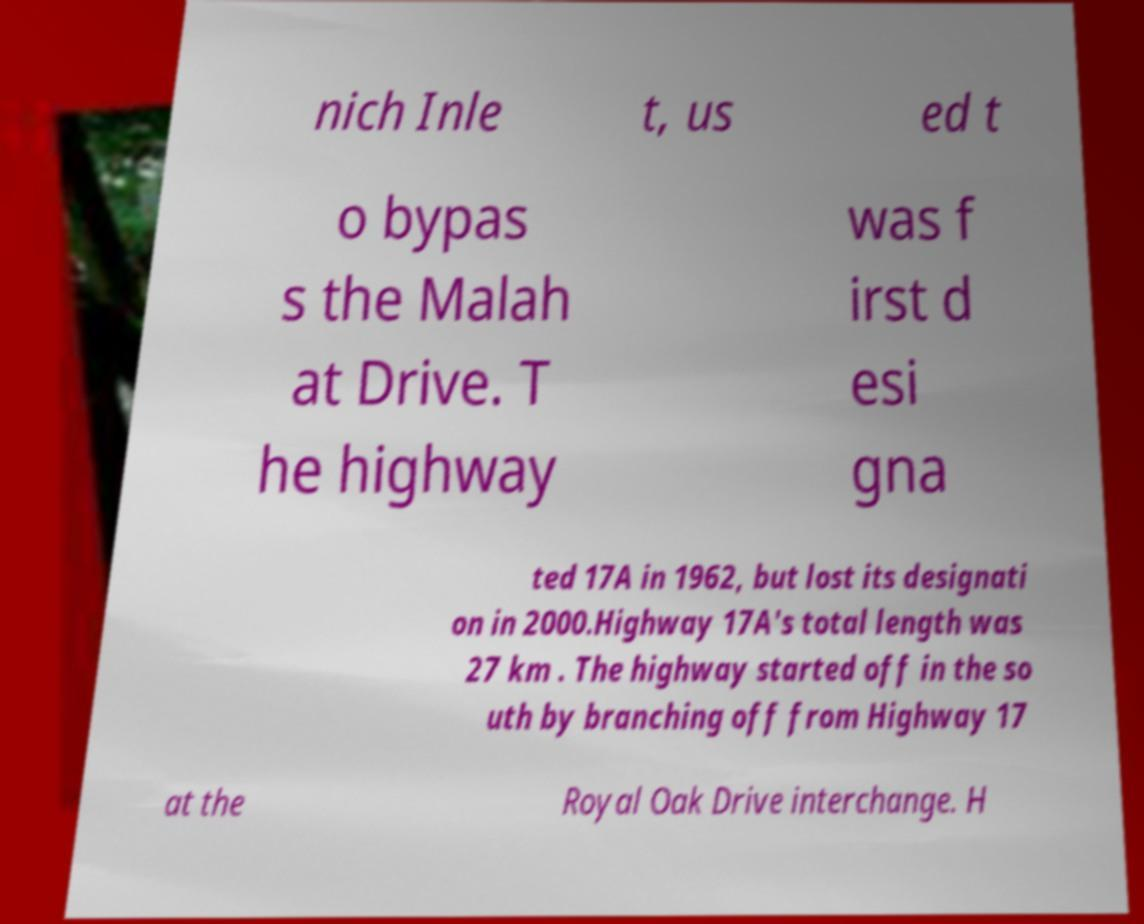Could you extract and type out the text from this image? nich Inle t, us ed t o bypas s the Malah at Drive. T he highway was f irst d esi gna ted 17A in 1962, but lost its designati on in 2000.Highway 17A's total length was 27 km . The highway started off in the so uth by branching off from Highway 17 at the Royal Oak Drive interchange. H 